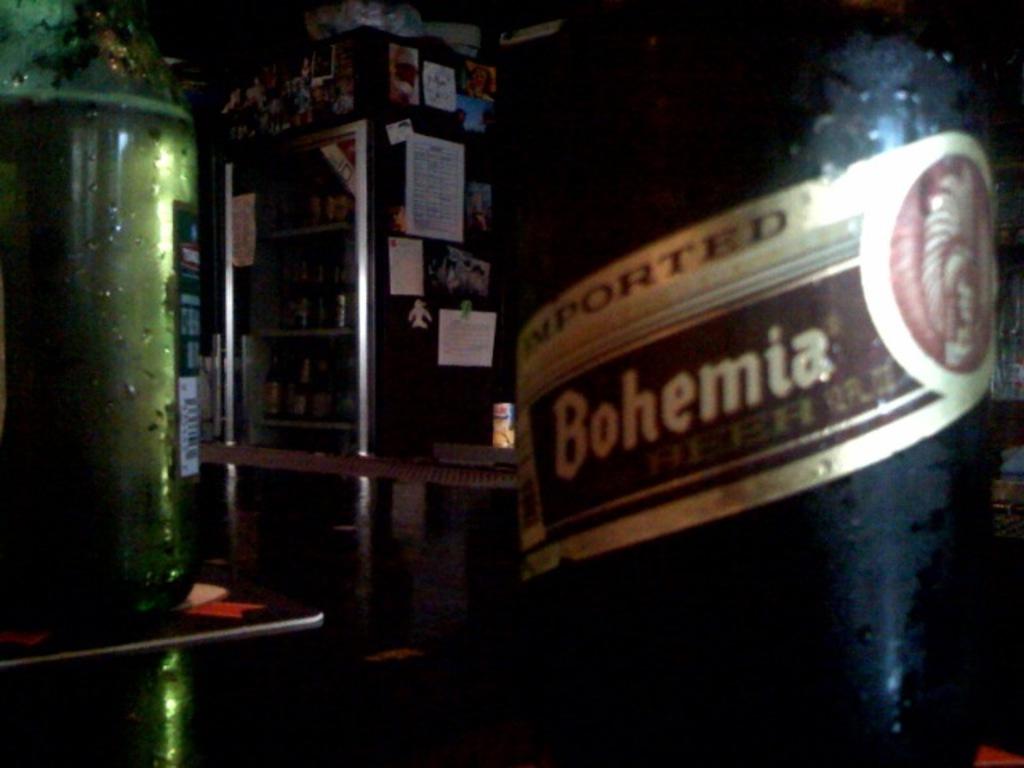Is this an imported or domestic drink?
Your answer should be very brief. Imported. 